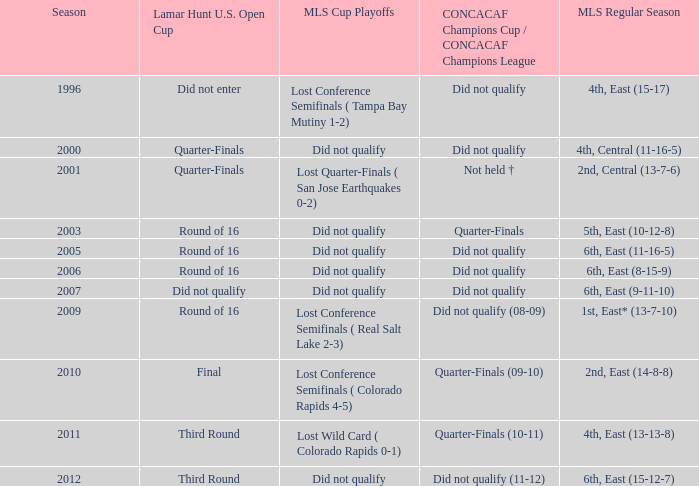What was the mls cup playoffs when concacaf champions cup / concacaf champions league was quarter-finals (09-10)? Lost Conference Semifinals ( Colorado Rapids 4-5). 